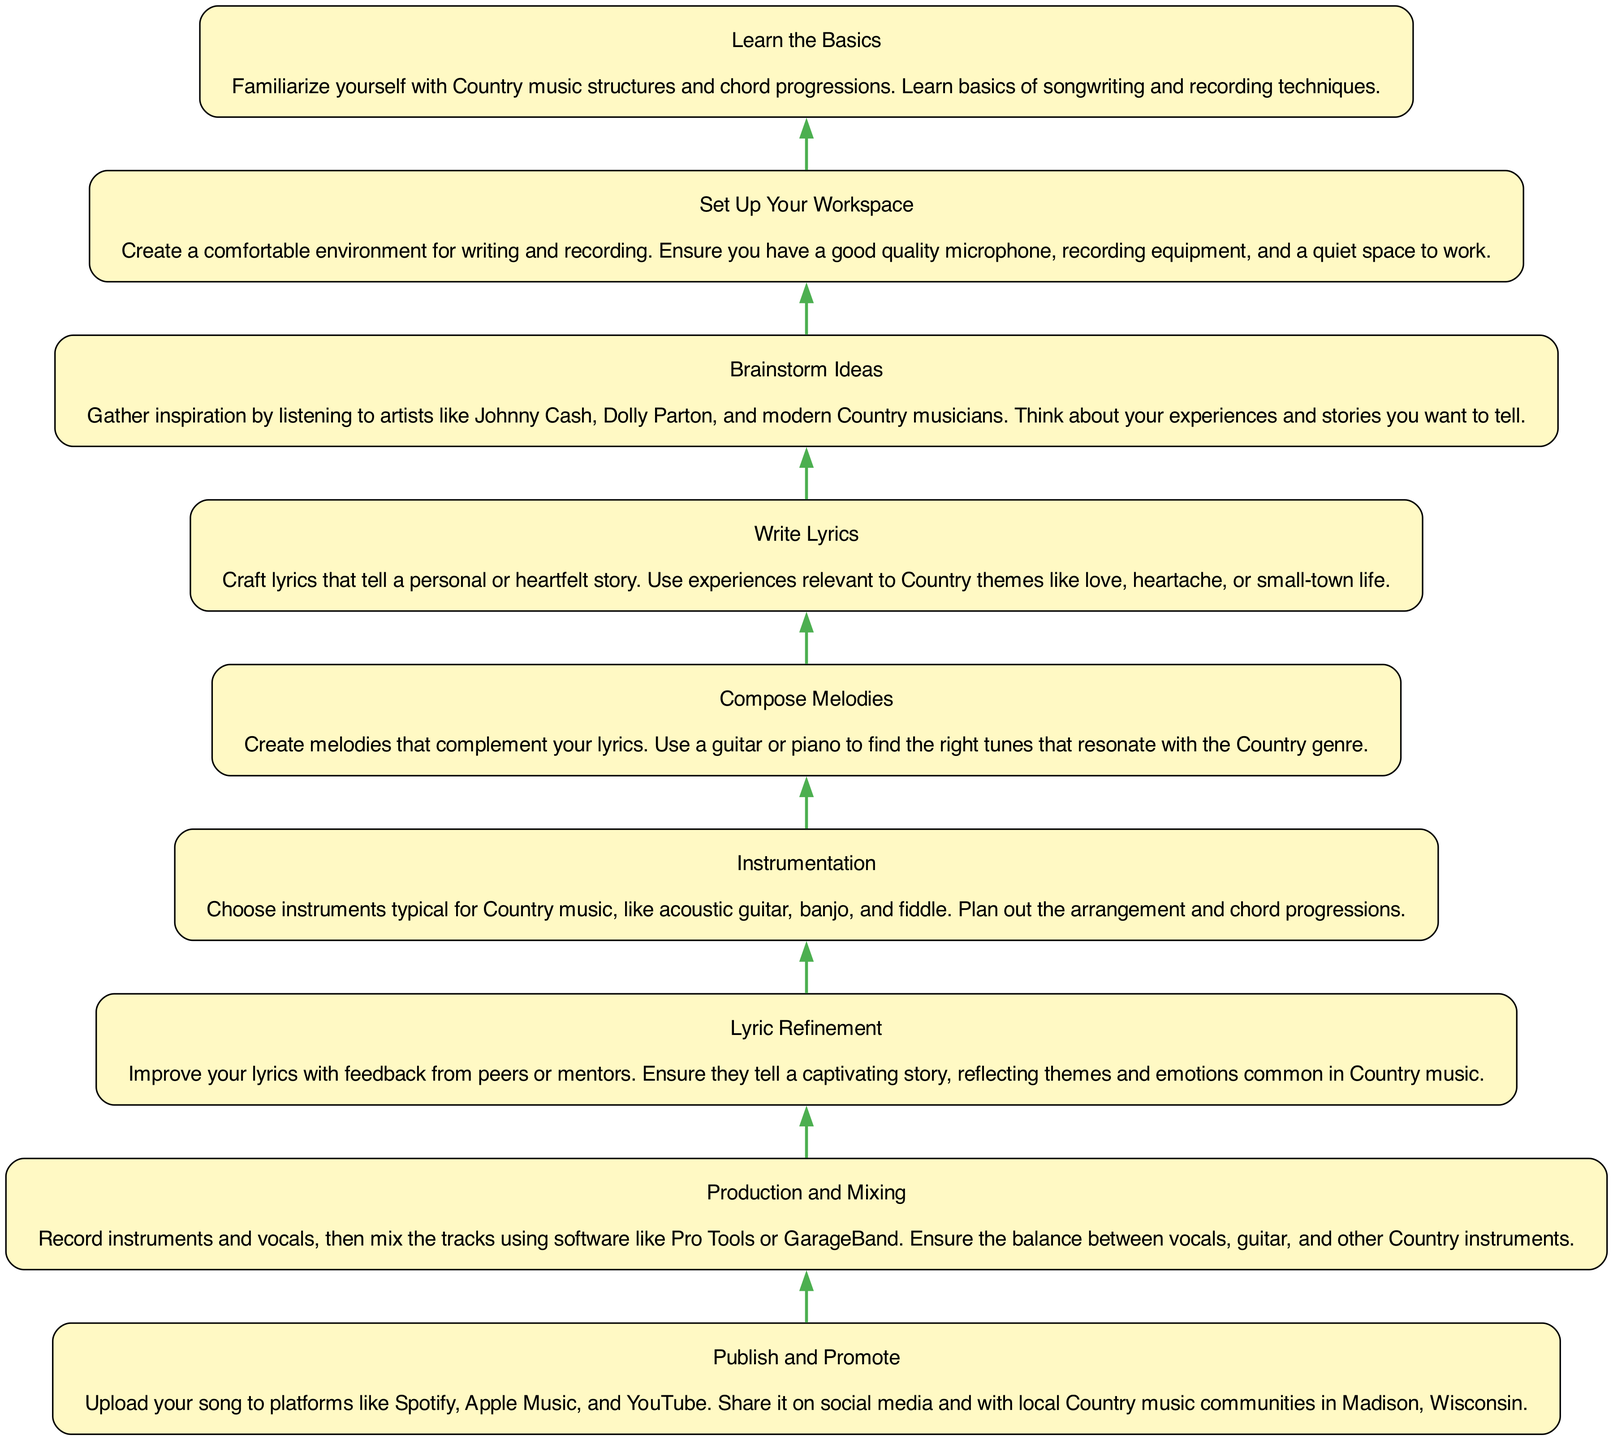What is the first step in writing a Country song? The diagram indicates that "Learn the Basics" is the initial step in the process. It identifies that one should familiarize themselves with Country music structures and songwriting basics before proceeding further.
Answer: Learn the Basics How many total steps are involved in the process? By counting the nodes in the diagram, we can see there are nine distinct steps outlined for writing and recording a Country song.
Answer: Nine Which step comes directly after "Brainstorm Ideas"? The diagram shows that "Write Lyrics" follows "Brainstorm Ideas," situated immediately above it in the flow chart structure.
Answer: Write Lyrics What is emphasized in the "Lyric Refinement" step? The description for "Lyric Refinement" highlights the importance of improving lyrics through feedback to ensure they tell a captivating story, focusing on common Country themes.
Answer: Captivating story What steps involve creating music elements? Referring to the diagram, both "Compose Melodies" and "Instrumentation" deal with creating essential music components; "Compose Melodies" focuses on melodies while "Instrumentation" addresses instrument choices.
Answer: Compose Melodies and Instrumentation Which steps are directly related to the recording process? The steps "Production and Mixing" and "Set Up Your Workspace" are directly linked to the recording process, as one involves preparing for recording, while the other is about recording and mixing tracks.
Answer: Production and Mixing, Set Up Your Workspace Is there a step focused on promoting the song? Yes, the last step "Publish and Promote" specifically addresses the promotion phase, detailing actions like uploading to platforms and sharing within local communities.
Answer: Publish and Promote What themes should the lyrics reflect? The lyrics should reflect themes and emotions common in Country music, as particularly emphasized in the "Lyric Refinement" step.
Answer: Country themes What instrument choices are suggested in the "Instrumentation" step? The "Instrumentation" step advises choosing typical Country instruments, specifically mentioning acoustic guitar, banjo, and fiddle.
Answer: Acoustic guitar, banjo, fiddle 